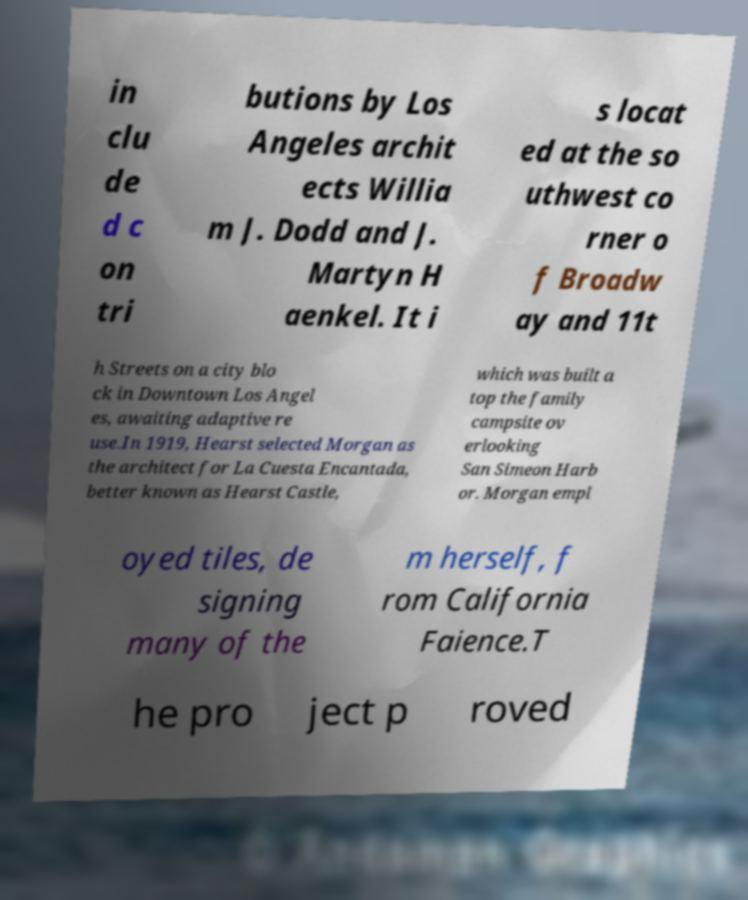Could you assist in decoding the text presented in this image and type it out clearly? in clu de d c on tri butions by Los Angeles archit ects Willia m J. Dodd and J. Martyn H aenkel. It i s locat ed at the so uthwest co rner o f Broadw ay and 11t h Streets on a city blo ck in Downtown Los Angel es, awaiting adaptive re use.In 1919, Hearst selected Morgan as the architect for La Cuesta Encantada, better known as Hearst Castle, which was built a top the family campsite ov erlooking San Simeon Harb or. Morgan empl oyed tiles, de signing many of the m herself, f rom California Faience.T he pro ject p roved 